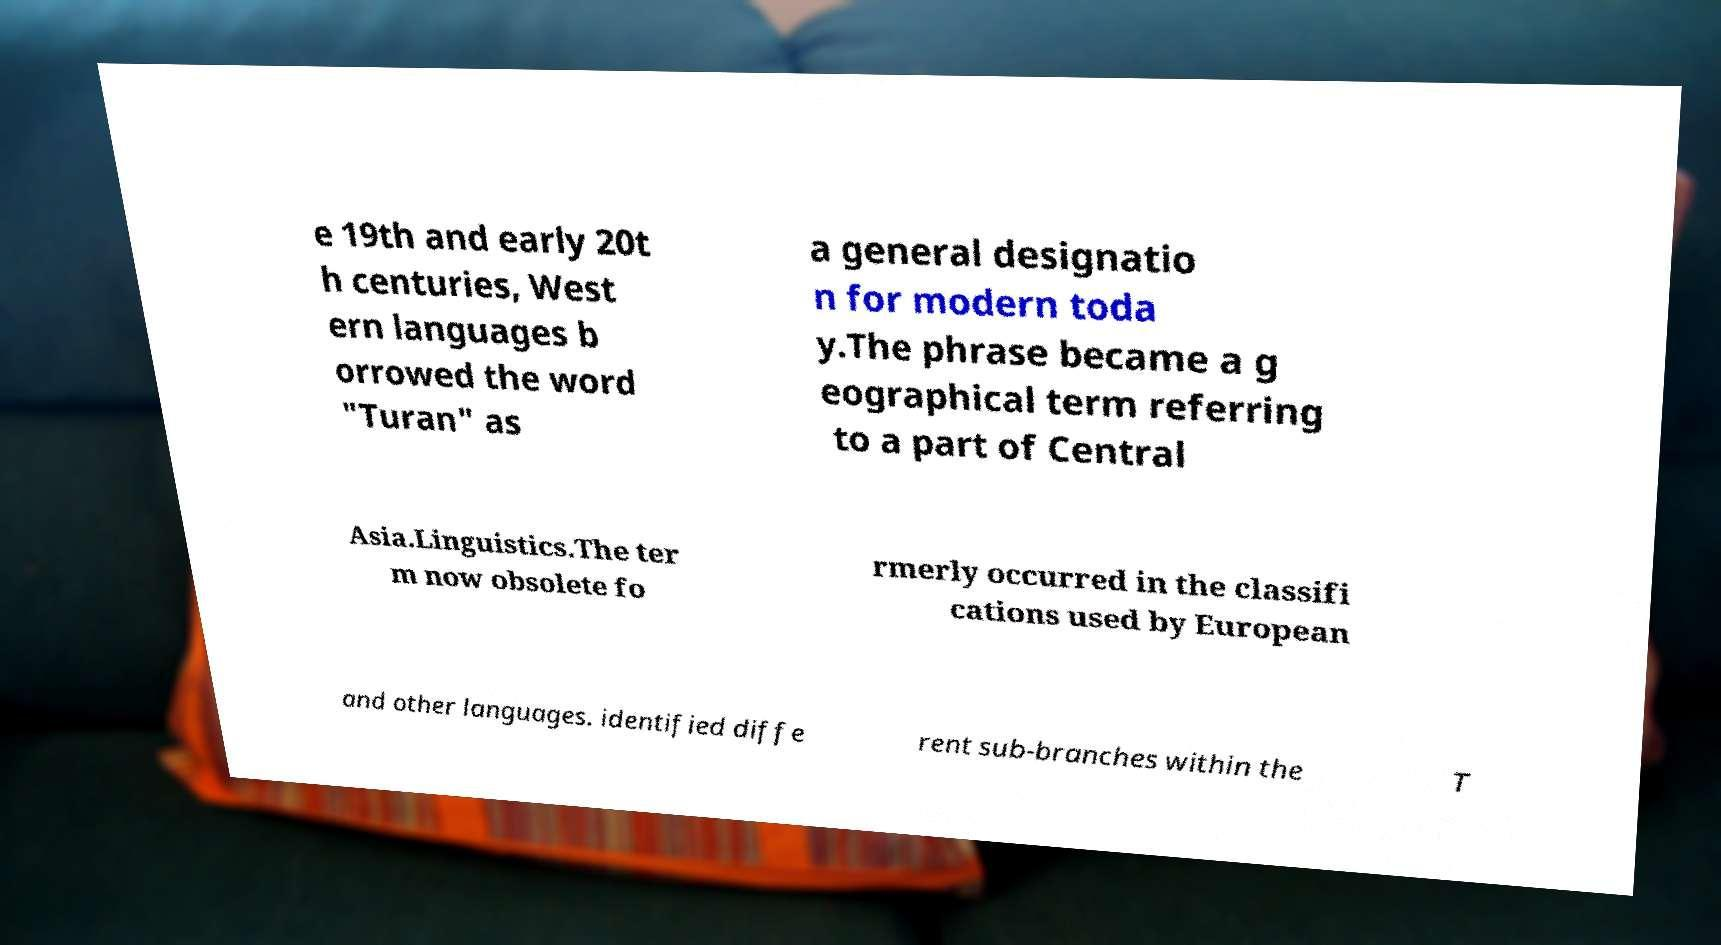Could you assist in decoding the text presented in this image and type it out clearly? e 19th and early 20t h centuries, West ern languages b orrowed the word "Turan" as a general designatio n for modern toda y.The phrase became a g eographical term referring to a part of Central Asia.Linguistics.The ter m now obsolete fo rmerly occurred in the classifi cations used by European and other languages. identified diffe rent sub-branches within the T 